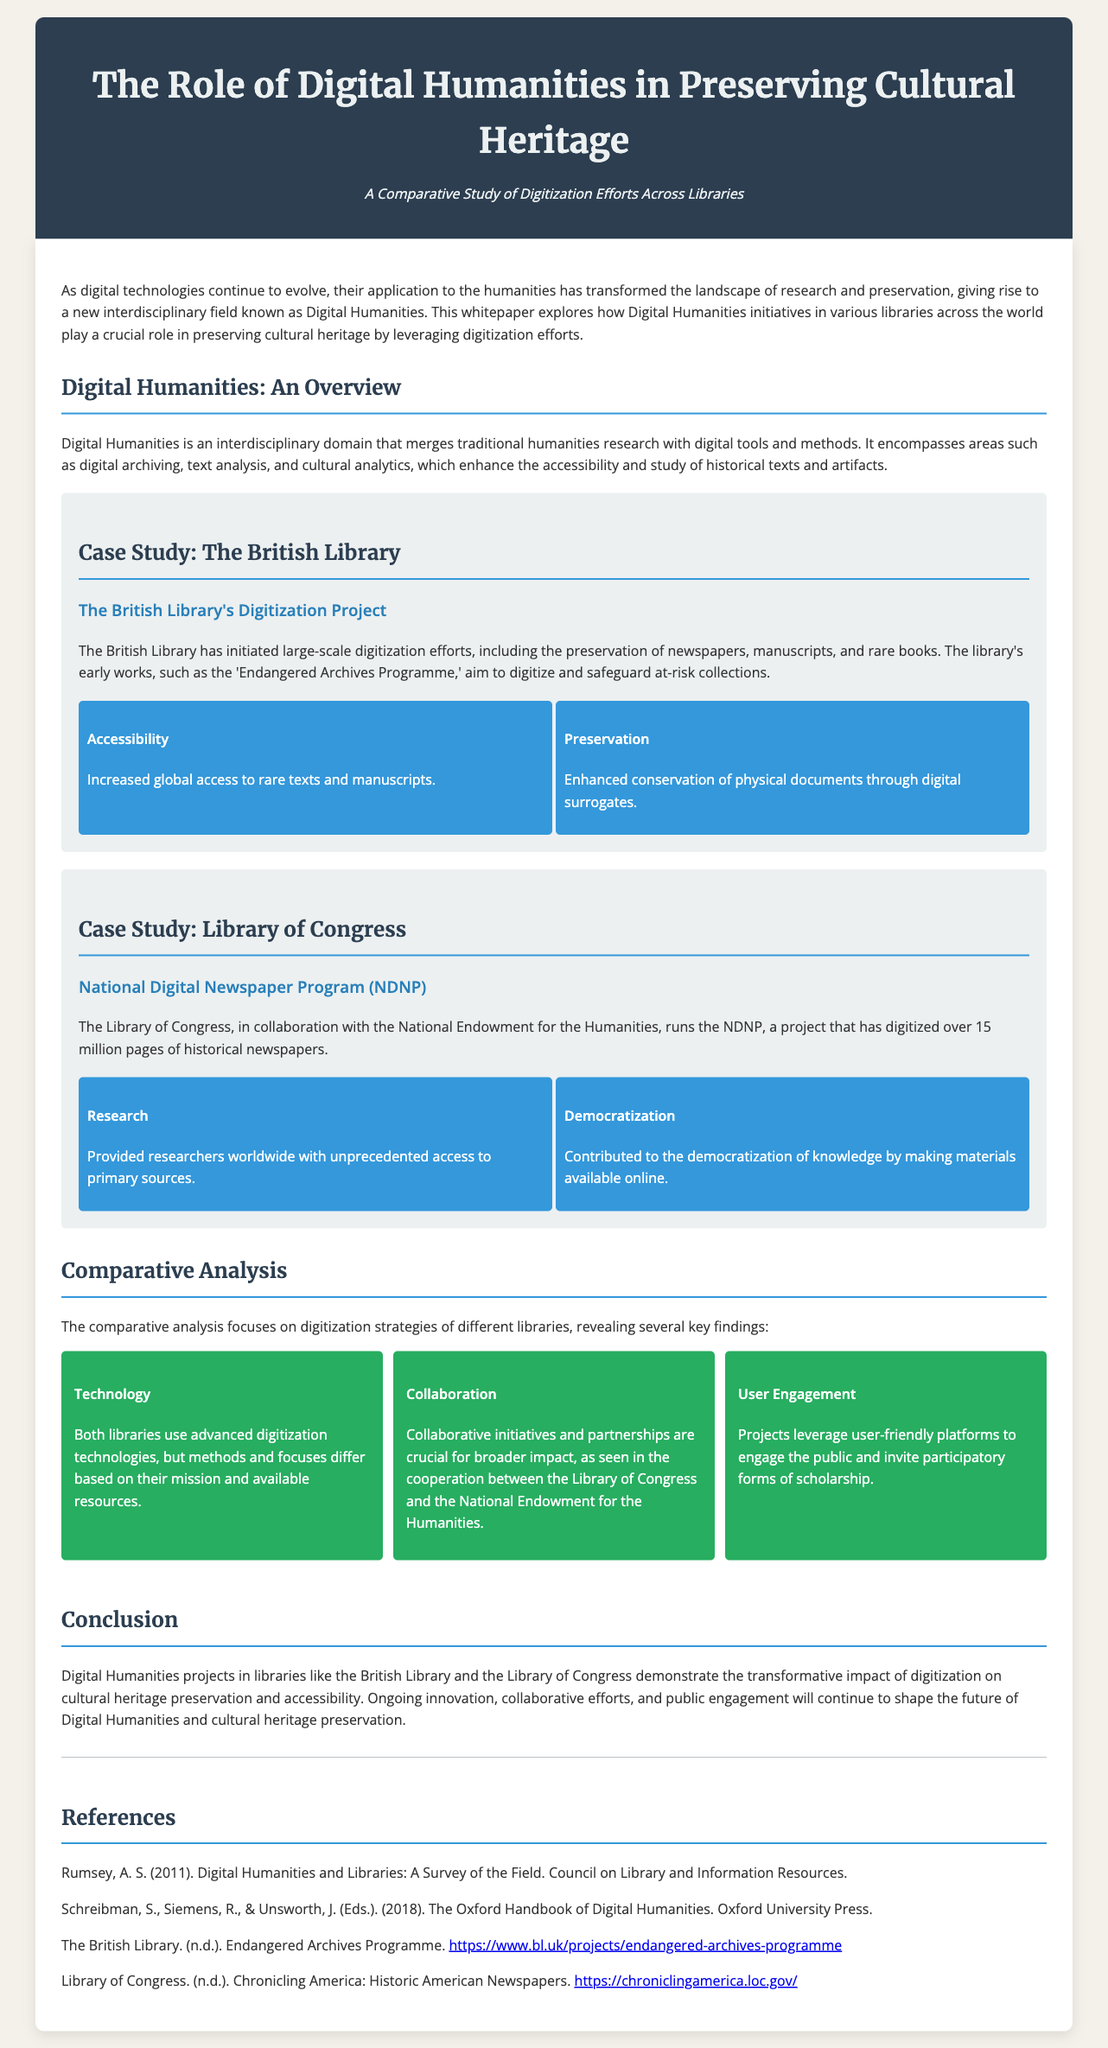what is the title of the whitepaper? The title is prominently displayed in the header of the document.
Answer: The Role of Digital Humanities in Preserving Cultural Heritage what project did the British Library initiate? The project is mentioned in the case study section about the British Library.
Answer: Endangered Archives Programme how many pages has the NDNP digitized? The digitization effort of the NDNP is highlighted in the case study of the Library of Congress.
Answer: 15 million pages which two libraries are primarily discussed in the whitepaper? The libraries are specifically mentioned in the case studies and throughout the document.
Answer: British Library and Library of Congress what is one impact of the British Library's digitization project? The document provides specific impacts in the impact section of the British Library case study.
Answer: Increased global access to rare texts and manuscripts what does the comparative analysis reveal about technology? The findings discussed in the comparative analysis section provide insights into this aspect.
Answer: Methods and focuses differ based on their mission and available resources what is a key collaborative initiative mentioned? The document refers specifically to the collaborative efforts in the context of the Library of Congress.
Answer: National Endowment for the Humanities what is the goal of Digital Humanities as described in the document? The introduction and overview sections provide a definition and purpose for Digital Humanities.
Answer: Preserving cultural heritage through digitization efforts what type of documents are digitized by the British Library? The case study details the types of historical documents the British Library focuses on in their efforts.
Answer: Newspapers, manuscripts, and rare books 